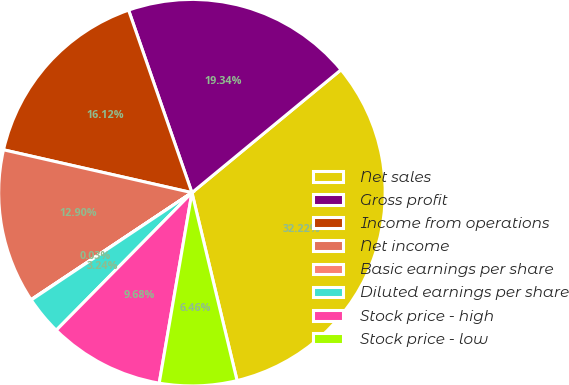Convert chart. <chart><loc_0><loc_0><loc_500><loc_500><pie_chart><fcel>Net sales<fcel>Gross profit<fcel>Income from operations<fcel>Net income<fcel>Basic earnings per share<fcel>Diluted earnings per share<fcel>Stock price - high<fcel>Stock price - low<nl><fcel>32.22%<fcel>19.34%<fcel>16.12%<fcel>12.9%<fcel>0.03%<fcel>3.24%<fcel>9.68%<fcel>6.46%<nl></chart> 